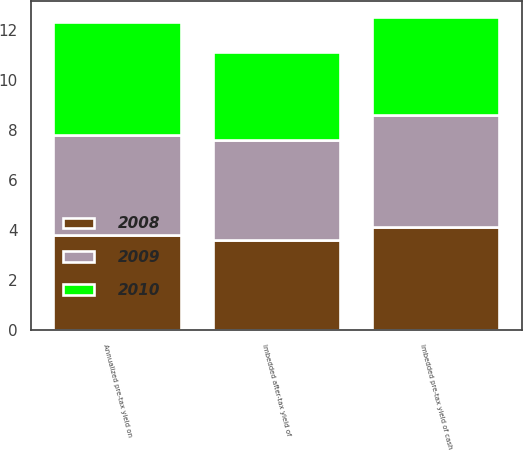Convert chart. <chart><loc_0><loc_0><loc_500><loc_500><stacked_bar_chart><ecel><fcel>Imbedded pre-tax yield of cash<fcel>Imbedded after-tax yield of<fcel>Annualized pre-tax yield on<nl><fcel>2010<fcel>3.9<fcel>3.5<fcel>4.5<nl><fcel>2008<fcel>4.1<fcel>3.6<fcel>3.8<nl><fcel>2009<fcel>4.5<fcel>4<fcel>4<nl></chart> 